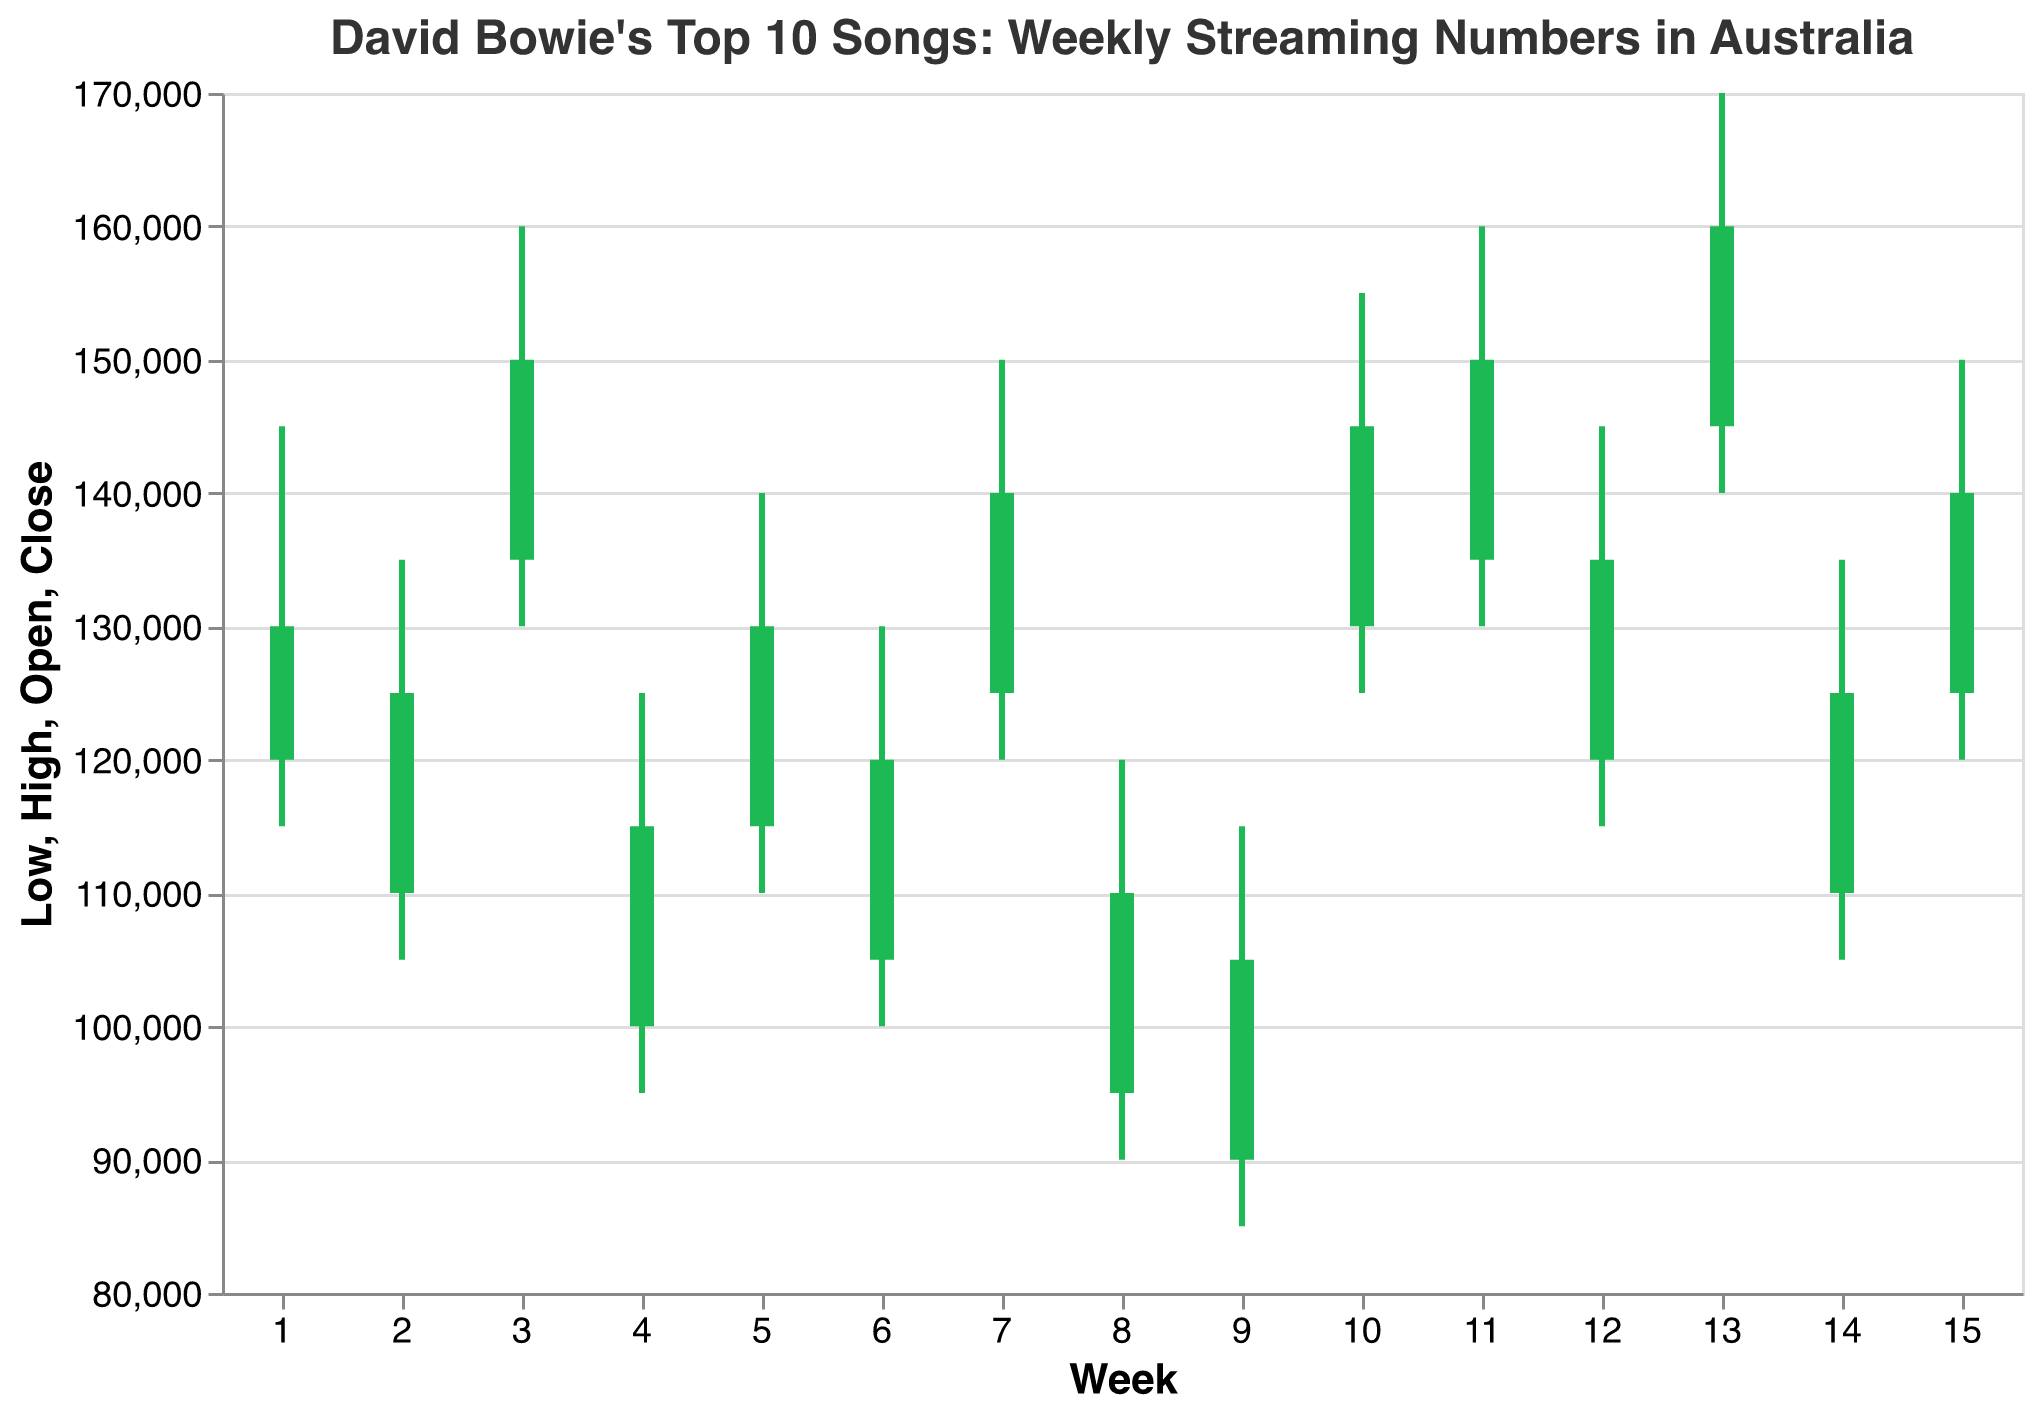What's the title of the figure? The title of the figure is located at the top of the chart. It usually gives a brief explanation of what the chart is depicting.
Answer: David Bowie's Top 10 Songs: Weekly Streaming Numbers in Australia What is the range of streaming numbers (High-Low) for "Let's Dance" in week 3? Locate the values for Week 3, "Let's Dance," and calculate the difference between High (160000) and Low (130000). 160000 - 130000 = 30000
Answer: 30000 Which song had the highest closing streaming numbers and what was the value? Compare the 'Close' values for each song. The highest closing number is for "Let's Dance" in Week 13, which is 160000.
Answer: Let's Dance, 160000 How many songs had a higher closing number than opening number in Week 2? Look at the color of the bars in Week 2. The green bars indicate a higher closing number than the opening number. "Heroes" is the only green bar in Week 2.
Answer: 1 Which week had the lowest high compared to the other weeks, and which song was it for? Compare the 'High' values across all weeks to find the lowest high. The lowest high is 120000 for "Modern Love" in Week 8.
Answer: Week 8, Modern Love What was the percentage increase from open to close for "Space Oddity" in Week 11? Calculate the percentage change using the formula ((Close - Open) / Open) * 100. For "Space Oddity" in Week 11: ((150000 - 135000) / 135000) * 100 = 11.11
Answer: 11.11% Which songs had the largest increase in streaming numbers from low to high in Week 10? Look at the difference between Low and High values for Week 10. Calculate for all songs and compare. "Ashes to Ashes" had the largest increase from 125000 (Low) to 155000 (High).
Answer: Ashes to Ashes Were there any weeks where no song had a lower close than open? If so, which week? Check each week's color bars and find the week where all bars are colored green, which signifies the close values are higher than open. Week 1 has no red bars, so no song had a lower close than open.
Answer: Week 1 For "Rebel Rebel" in Week 7, what is the average of the Open, High, Low, and Close values? Calculate the average by adding the four values (125000 + 150000 + 120000 + 140000) and then dividing by 4. (125000 + 150000 + 120000 + 140000) / 4 = 133750
Answer: 133750 